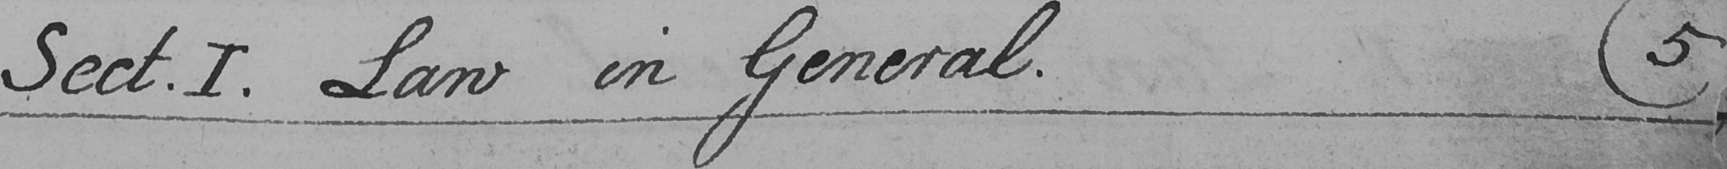Can you tell me what this handwritten text says? Sect . I . Law in General .  ( 5 